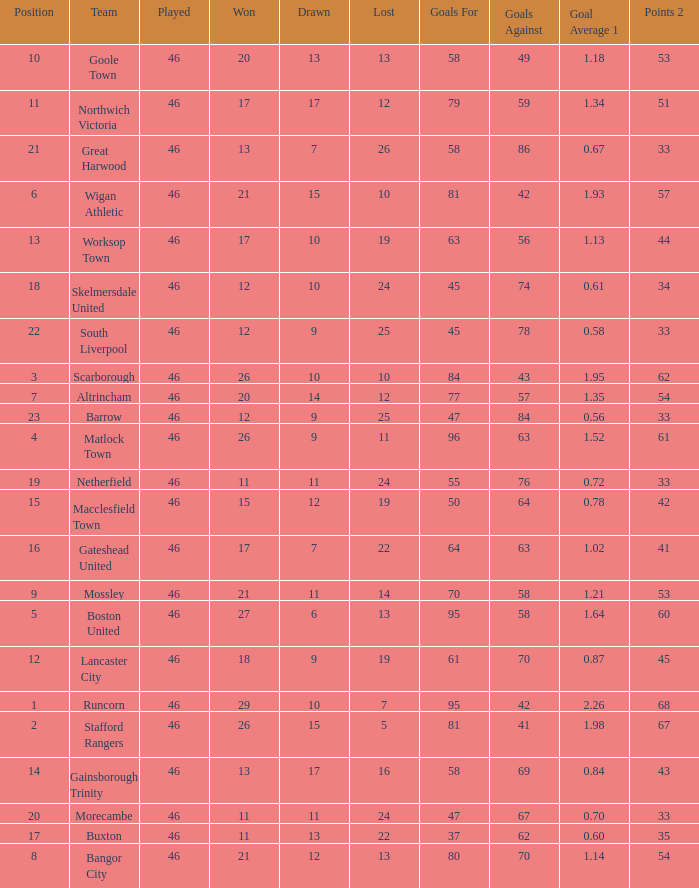Parse the full table. {'header': ['Position', 'Team', 'Played', 'Won', 'Drawn', 'Lost', 'Goals For', 'Goals Against', 'Goal Average 1', 'Points 2'], 'rows': [['10', 'Goole Town', '46', '20', '13', '13', '58', '49', '1.18', '53'], ['11', 'Northwich Victoria', '46', '17', '17', '12', '79', '59', '1.34', '51'], ['21', 'Great Harwood', '46', '13', '7', '26', '58', '86', '0.67', '33'], ['6', 'Wigan Athletic', '46', '21', '15', '10', '81', '42', '1.93', '57'], ['13', 'Worksop Town', '46', '17', '10', '19', '63', '56', '1.13', '44'], ['18', 'Skelmersdale United', '46', '12', '10', '24', '45', '74', '0.61', '34'], ['22', 'South Liverpool', '46', '12', '9', '25', '45', '78', '0.58', '33'], ['3', 'Scarborough', '46', '26', '10', '10', '84', '43', '1.95', '62'], ['7', 'Altrincham', '46', '20', '14', '12', '77', '57', '1.35', '54'], ['23', 'Barrow', '46', '12', '9', '25', '47', '84', '0.56', '33'], ['4', 'Matlock Town', '46', '26', '9', '11', '96', '63', '1.52', '61'], ['19', 'Netherfield', '46', '11', '11', '24', '55', '76', '0.72', '33'], ['15', 'Macclesfield Town', '46', '15', '12', '19', '50', '64', '0.78', '42'], ['16', 'Gateshead United', '46', '17', '7', '22', '64', '63', '1.02', '41'], ['9', 'Mossley', '46', '21', '11', '14', '70', '58', '1.21', '53'], ['5', 'Boston United', '46', '27', '6', '13', '95', '58', '1.64', '60'], ['12', 'Lancaster City', '46', '18', '9', '19', '61', '70', '0.87', '45'], ['1', 'Runcorn', '46', '29', '10', '7', '95', '42', '2.26', '68'], ['2', 'Stafford Rangers', '46', '26', '15', '5', '81', '41', '1.98', '67'], ['14', 'Gainsborough Trinity', '46', '13', '17', '16', '58', '69', '0.84', '43'], ['20', 'Morecambe', '46', '11', '11', '24', '47', '67', '0.70', '33'], ['17', 'Buxton', '46', '11', '13', '22', '37', '62', '0.60', '35'], ['8', 'Bangor City', '46', '21', '12', '13', '80', '70', '1.14', '54']]} Which team had goal averages of 1.34? Northwich Victoria. 